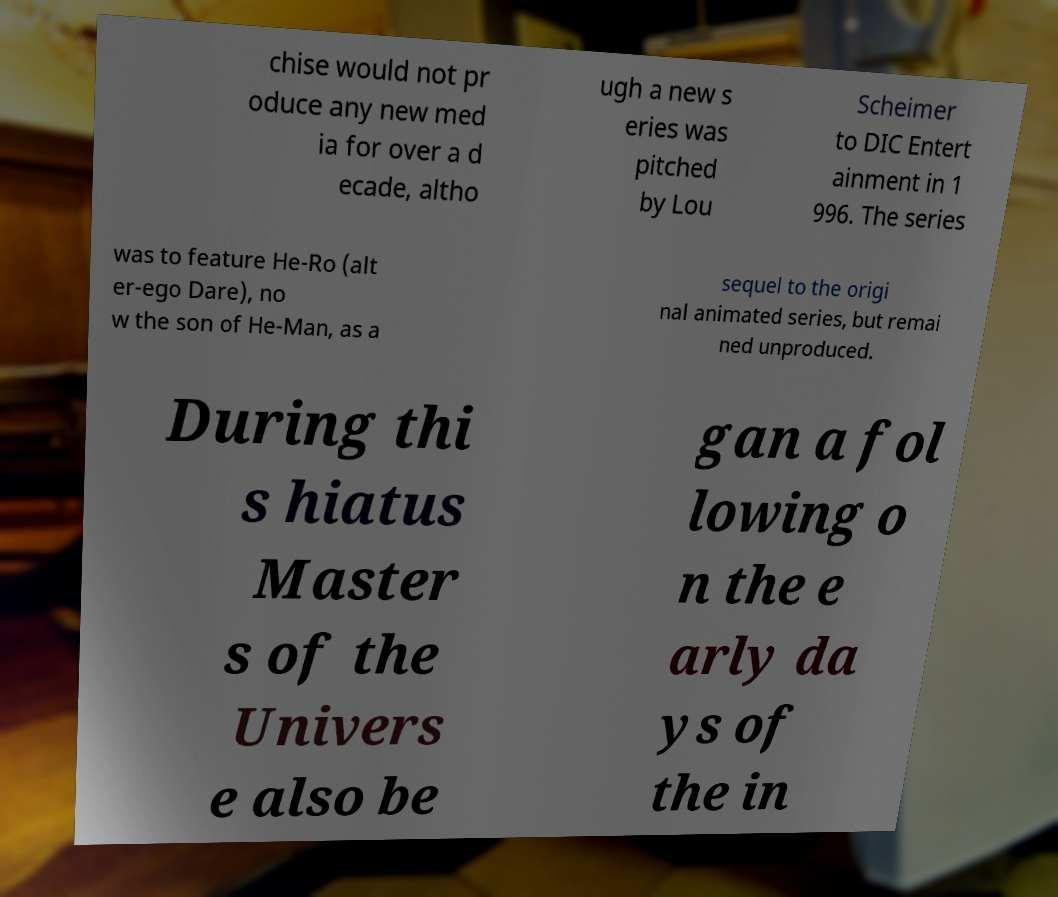Please identify and transcribe the text found in this image. chise would not pr oduce any new med ia for over a d ecade, altho ugh a new s eries was pitched by Lou Scheimer to DIC Entert ainment in 1 996. The series was to feature He-Ro (alt er-ego Dare), no w the son of He-Man, as a sequel to the origi nal animated series, but remai ned unproduced. During thi s hiatus Master s of the Univers e also be gan a fol lowing o n the e arly da ys of the in 